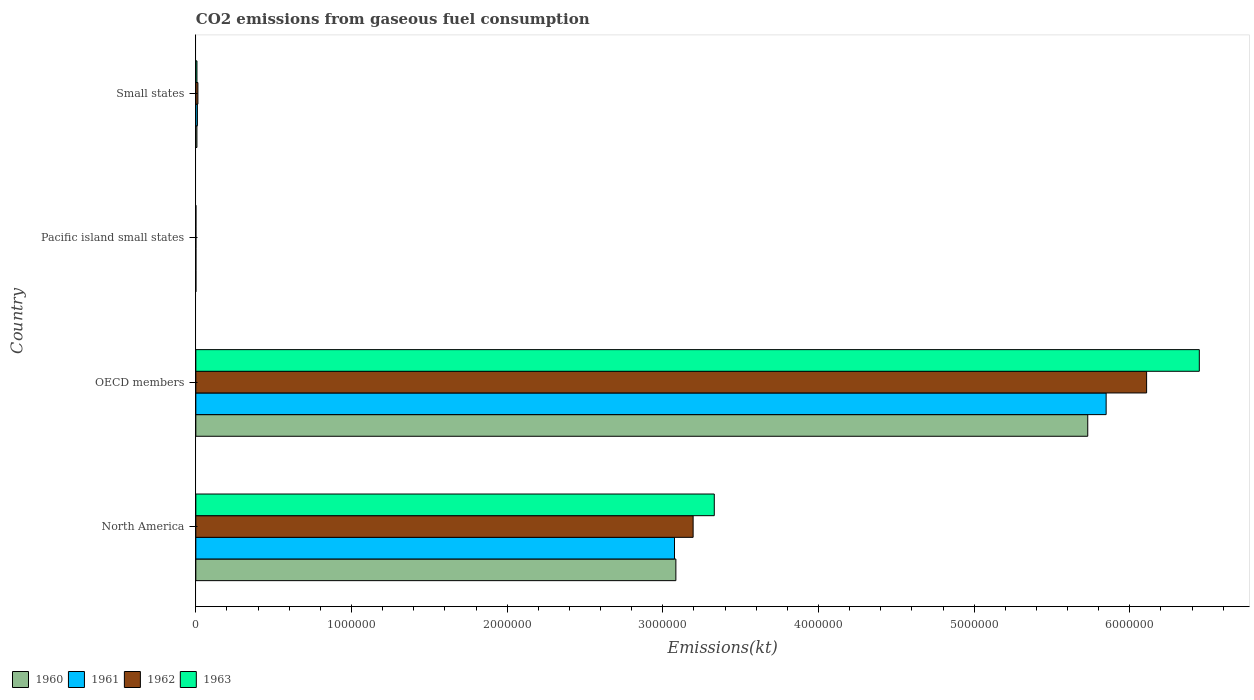Are the number of bars per tick equal to the number of legend labels?
Make the answer very short. Yes. Are the number of bars on each tick of the Y-axis equal?
Your answer should be very brief. Yes. How many bars are there on the 3rd tick from the bottom?
Ensure brevity in your answer.  4. What is the label of the 1st group of bars from the top?
Your answer should be compact. Small states. What is the amount of CO2 emitted in 1961 in North America?
Ensure brevity in your answer.  3.07e+06. Across all countries, what is the maximum amount of CO2 emitted in 1960?
Give a very brief answer. 5.73e+06. Across all countries, what is the minimum amount of CO2 emitted in 1961?
Make the answer very short. 332.61. In which country was the amount of CO2 emitted in 1963 minimum?
Your answer should be very brief. Pacific island small states. What is the total amount of CO2 emitted in 1960 in the graph?
Make the answer very short. 8.82e+06. What is the difference between the amount of CO2 emitted in 1961 in OECD members and that in Pacific island small states?
Offer a very short reply. 5.85e+06. What is the difference between the amount of CO2 emitted in 1962 in OECD members and the amount of CO2 emitted in 1963 in North America?
Make the answer very short. 2.78e+06. What is the average amount of CO2 emitted in 1961 per country?
Your response must be concise. 2.23e+06. What is the difference between the amount of CO2 emitted in 1962 and amount of CO2 emitted in 1960 in Pacific island small states?
Your answer should be very brief. 104. In how many countries, is the amount of CO2 emitted in 1960 greater than 3000000 kt?
Give a very brief answer. 2. What is the ratio of the amount of CO2 emitted in 1960 in North America to that in OECD members?
Offer a very short reply. 0.54. Is the amount of CO2 emitted in 1963 in OECD members less than that in Small states?
Make the answer very short. No. Is the difference between the amount of CO2 emitted in 1962 in Pacific island small states and Small states greater than the difference between the amount of CO2 emitted in 1960 in Pacific island small states and Small states?
Provide a succinct answer. No. What is the difference between the highest and the second highest amount of CO2 emitted in 1963?
Provide a short and direct response. 3.12e+06. What is the difference between the highest and the lowest amount of CO2 emitted in 1963?
Make the answer very short. 6.45e+06. In how many countries, is the amount of CO2 emitted in 1961 greater than the average amount of CO2 emitted in 1961 taken over all countries?
Your response must be concise. 2. Is the sum of the amount of CO2 emitted in 1963 in OECD members and Pacific island small states greater than the maximum amount of CO2 emitted in 1960 across all countries?
Your response must be concise. Yes. What does the 2nd bar from the top in Small states represents?
Your answer should be very brief. 1962. Are all the bars in the graph horizontal?
Offer a very short reply. Yes. Are the values on the major ticks of X-axis written in scientific E-notation?
Your answer should be compact. No. Does the graph contain any zero values?
Provide a succinct answer. No. How many legend labels are there?
Keep it short and to the point. 4. What is the title of the graph?
Provide a short and direct response. CO2 emissions from gaseous fuel consumption. What is the label or title of the X-axis?
Offer a terse response. Emissions(kt). What is the label or title of the Y-axis?
Make the answer very short. Country. What is the Emissions(kt) of 1960 in North America?
Ensure brevity in your answer.  3.08e+06. What is the Emissions(kt) in 1961 in North America?
Keep it short and to the point. 3.07e+06. What is the Emissions(kt) of 1962 in North America?
Your answer should be compact. 3.19e+06. What is the Emissions(kt) of 1963 in North America?
Your answer should be very brief. 3.33e+06. What is the Emissions(kt) in 1960 in OECD members?
Keep it short and to the point. 5.73e+06. What is the Emissions(kt) of 1961 in OECD members?
Keep it short and to the point. 5.85e+06. What is the Emissions(kt) of 1962 in OECD members?
Give a very brief answer. 6.11e+06. What is the Emissions(kt) in 1963 in OECD members?
Your answer should be very brief. 6.45e+06. What is the Emissions(kt) in 1960 in Pacific island small states?
Ensure brevity in your answer.  309.51. What is the Emissions(kt) in 1961 in Pacific island small states?
Ensure brevity in your answer.  332.61. What is the Emissions(kt) of 1962 in Pacific island small states?
Provide a short and direct response. 413.52. What is the Emissions(kt) in 1963 in Pacific island small states?
Give a very brief answer. 433.59. What is the Emissions(kt) of 1960 in Small states?
Your answer should be very brief. 7013.94. What is the Emissions(kt) in 1961 in Small states?
Ensure brevity in your answer.  1.02e+04. What is the Emissions(kt) of 1962 in Small states?
Your answer should be compact. 1.34e+04. What is the Emissions(kt) in 1963 in Small states?
Offer a very short reply. 7256.39. Across all countries, what is the maximum Emissions(kt) of 1960?
Ensure brevity in your answer.  5.73e+06. Across all countries, what is the maximum Emissions(kt) in 1961?
Your answer should be very brief. 5.85e+06. Across all countries, what is the maximum Emissions(kt) in 1962?
Your answer should be very brief. 6.11e+06. Across all countries, what is the maximum Emissions(kt) of 1963?
Your answer should be very brief. 6.45e+06. Across all countries, what is the minimum Emissions(kt) of 1960?
Your answer should be very brief. 309.51. Across all countries, what is the minimum Emissions(kt) of 1961?
Ensure brevity in your answer.  332.61. Across all countries, what is the minimum Emissions(kt) in 1962?
Make the answer very short. 413.52. Across all countries, what is the minimum Emissions(kt) of 1963?
Ensure brevity in your answer.  433.59. What is the total Emissions(kt) in 1960 in the graph?
Keep it short and to the point. 8.82e+06. What is the total Emissions(kt) in 1961 in the graph?
Your response must be concise. 8.93e+06. What is the total Emissions(kt) of 1962 in the graph?
Provide a short and direct response. 9.32e+06. What is the total Emissions(kt) in 1963 in the graph?
Your answer should be very brief. 9.78e+06. What is the difference between the Emissions(kt) of 1960 in North America and that in OECD members?
Offer a terse response. -2.65e+06. What is the difference between the Emissions(kt) in 1961 in North America and that in OECD members?
Provide a succinct answer. -2.77e+06. What is the difference between the Emissions(kt) of 1962 in North America and that in OECD members?
Provide a succinct answer. -2.91e+06. What is the difference between the Emissions(kt) of 1963 in North America and that in OECD members?
Offer a very short reply. -3.12e+06. What is the difference between the Emissions(kt) in 1960 in North America and that in Pacific island small states?
Provide a succinct answer. 3.08e+06. What is the difference between the Emissions(kt) in 1961 in North America and that in Pacific island small states?
Give a very brief answer. 3.07e+06. What is the difference between the Emissions(kt) of 1962 in North America and that in Pacific island small states?
Offer a very short reply. 3.19e+06. What is the difference between the Emissions(kt) of 1963 in North America and that in Pacific island small states?
Ensure brevity in your answer.  3.33e+06. What is the difference between the Emissions(kt) of 1960 in North America and that in Small states?
Your response must be concise. 3.08e+06. What is the difference between the Emissions(kt) in 1961 in North America and that in Small states?
Make the answer very short. 3.06e+06. What is the difference between the Emissions(kt) of 1962 in North America and that in Small states?
Provide a short and direct response. 3.18e+06. What is the difference between the Emissions(kt) of 1963 in North America and that in Small states?
Ensure brevity in your answer.  3.32e+06. What is the difference between the Emissions(kt) in 1960 in OECD members and that in Pacific island small states?
Keep it short and to the point. 5.73e+06. What is the difference between the Emissions(kt) in 1961 in OECD members and that in Pacific island small states?
Your answer should be very brief. 5.85e+06. What is the difference between the Emissions(kt) of 1962 in OECD members and that in Pacific island small states?
Keep it short and to the point. 6.11e+06. What is the difference between the Emissions(kt) of 1963 in OECD members and that in Pacific island small states?
Your answer should be very brief. 6.45e+06. What is the difference between the Emissions(kt) of 1960 in OECD members and that in Small states?
Keep it short and to the point. 5.72e+06. What is the difference between the Emissions(kt) in 1961 in OECD members and that in Small states?
Your answer should be very brief. 5.84e+06. What is the difference between the Emissions(kt) in 1962 in OECD members and that in Small states?
Provide a succinct answer. 6.09e+06. What is the difference between the Emissions(kt) of 1963 in OECD members and that in Small states?
Your answer should be compact. 6.44e+06. What is the difference between the Emissions(kt) in 1960 in Pacific island small states and that in Small states?
Your response must be concise. -6704.42. What is the difference between the Emissions(kt) in 1961 in Pacific island small states and that in Small states?
Offer a very short reply. -9836.23. What is the difference between the Emissions(kt) of 1962 in Pacific island small states and that in Small states?
Provide a succinct answer. -1.30e+04. What is the difference between the Emissions(kt) of 1963 in Pacific island small states and that in Small states?
Keep it short and to the point. -6822.8. What is the difference between the Emissions(kt) in 1960 in North America and the Emissions(kt) in 1961 in OECD members?
Your answer should be compact. -2.76e+06. What is the difference between the Emissions(kt) of 1960 in North America and the Emissions(kt) of 1962 in OECD members?
Your response must be concise. -3.02e+06. What is the difference between the Emissions(kt) of 1960 in North America and the Emissions(kt) of 1963 in OECD members?
Give a very brief answer. -3.36e+06. What is the difference between the Emissions(kt) in 1961 in North America and the Emissions(kt) in 1962 in OECD members?
Provide a succinct answer. -3.03e+06. What is the difference between the Emissions(kt) of 1961 in North America and the Emissions(kt) of 1963 in OECD members?
Keep it short and to the point. -3.37e+06. What is the difference between the Emissions(kt) in 1962 in North America and the Emissions(kt) in 1963 in OECD members?
Provide a succinct answer. -3.25e+06. What is the difference between the Emissions(kt) of 1960 in North America and the Emissions(kt) of 1961 in Pacific island small states?
Provide a short and direct response. 3.08e+06. What is the difference between the Emissions(kt) in 1960 in North America and the Emissions(kt) in 1962 in Pacific island small states?
Give a very brief answer. 3.08e+06. What is the difference between the Emissions(kt) in 1960 in North America and the Emissions(kt) in 1963 in Pacific island small states?
Your answer should be very brief. 3.08e+06. What is the difference between the Emissions(kt) in 1961 in North America and the Emissions(kt) in 1962 in Pacific island small states?
Keep it short and to the point. 3.07e+06. What is the difference between the Emissions(kt) of 1961 in North America and the Emissions(kt) of 1963 in Pacific island small states?
Your response must be concise. 3.07e+06. What is the difference between the Emissions(kt) of 1962 in North America and the Emissions(kt) of 1963 in Pacific island small states?
Keep it short and to the point. 3.19e+06. What is the difference between the Emissions(kt) in 1960 in North America and the Emissions(kt) in 1961 in Small states?
Your response must be concise. 3.07e+06. What is the difference between the Emissions(kt) of 1960 in North America and the Emissions(kt) of 1962 in Small states?
Give a very brief answer. 3.07e+06. What is the difference between the Emissions(kt) in 1960 in North America and the Emissions(kt) in 1963 in Small states?
Make the answer very short. 3.08e+06. What is the difference between the Emissions(kt) in 1961 in North America and the Emissions(kt) in 1962 in Small states?
Provide a short and direct response. 3.06e+06. What is the difference between the Emissions(kt) in 1961 in North America and the Emissions(kt) in 1963 in Small states?
Give a very brief answer. 3.07e+06. What is the difference between the Emissions(kt) in 1962 in North America and the Emissions(kt) in 1963 in Small states?
Your response must be concise. 3.19e+06. What is the difference between the Emissions(kt) in 1960 in OECD members and the Emissions(kt) in 1961 in Pacific island small states?
Give a very brief answer. 5.73e+06. What is the difference between the Emissions(kt) in 1960 in OECD members and the Emissions(kt) in 1962 in Pacific island small states?
Offer a terse response. 5.73e+06. What is the difference between the Emissions(kt) in 1960 in OECD members and the Emissions(kt) in 1963 in Pacific island small states?
Your answer should be compact. 5.73e+06. What is the difference between the Emissions(kt) of 1961 in OECD members and the Emissions(kt) of 1962 in Pacific island small states?
Make the answer very short. 5.85e+06. What is the difference between the Emissions(kt) of 1961 in OECD members and the Emissions(kt) of 1963 in Pacific island small states?
Give a very brief answer. 5.85e+06. What is the difference between the Emissions(kt) in 1962 in OECD members and the Emissions(kt) in 1963 in Pacific island small states?
Give a very brief answer. 6.11e+06. What is the difference between the Emissions(kt) of 1960 in OECD members and the Emissions(kt) of 1961 in Small states?
Provide a succinct answer. 5.72e+06. What is the difference between the Emissions(kt) in 1960 in OECD members and the Emissions(kt) in 1962 in Small states?
Give a very brief answer. 5.72e+06. What is the difference between the Emissions(kt) in 1960 in OECD members and the Emissions(kt) in 1963 in Small states?
Give a very brief answer. 5.72e+06. What is the difference between the Emissions(kt) of 1961 in OECD members and the Emissions(kt) of 1962 in Small states?
Your answer should be very brief. 5.83e+06. What is the difference between the Emissions(kt) in 1961 in OECD members and the Emissions(kt) in 1963 in Small states?
Your answer should be compact. 5.84e+06. What is the difference between the Emissions(kt) in 1962 in OECD members and the Emissions(kt) in 1963 in Small states?
Make the answer very short. 6.10e+06. What is the difference between the Emissions(kt) in 1960 in Pacific island small states and the Emissions(kt) in 1961 in Small states?
Ensure brevity in your answer.  -9859.33. What is the difference between the Emissions(kt) in 1960 in Pacific island small states and the Emissions(kt) in 1962 in Small states?
Keep it short and to the point. -1.31e+04. What is the difference between the Emissions(kt) of 1960 in Pacific island small states and the Emissions(kt) of 1963 in Small states?
Ensure brevity in your answer.  -6946.87. What is the difference between the Emissions(kt) in 1961 in Pacific island small states and the Emissions(kt) in 1962 in Small states?
Offer a very short reply. -1.31e+04. What is the difference between the Emissions(kt) in 1961 in Pacific island small states and the Emissions(kt) in 1963 in Small states?
Your answer should be compact. -6923.78. What is the difference between the Emissions(kt) of 1962 in Pacific island small states and the Emissions(kt) of 1963 in Small states?
Ensure brevity in your answer.  -6842.87. What is the average Emissions(kt) of 1960 per country?
Your answer should be compact. 2.21e+06. What is the average Emissions(kt) of 1961 per country?
Offer a very short reply. 2.23e+06. What is the average Emissions(kt) of 1962 per country?
Provide a short and direct response. 2.33e+06. What is the average Emissions(kt) in 1963 per country?
Your response must be concise. 2.45e+06. What is the difference between the Emissions(kt) of 1960 and Emissions(kt) of 1961 in North America?
Your answer should be compact. 8885.14. What is the difference between the Emissions(kt) in 1960 and Emissions(kt) in 1962 in North America?
Provide a short and direct response. -1.11e+05. What is the difference between the Emissions(kt) in 1960 and Emissions(kt) in 1963 in North America?
Your answer should be very brief. -2.47e+05. What is the difference between the Emissions(kt) of 1961 and Emissions(kt) of 1962 in North America?
Ensure brevity in your answer.  -1.20e+05. What is the difference between the Emissions(kt) of 1961 and Emissions(kt) of 1963 in North America?
Give a very brief answer. -2.56e+05. What is the difference between the Emissions(kt) in 1962 and Emissions(kt) in 1963 in North America?
Provide a short and direct response. -1.36e+05. What is the difference between the Emissions(kt) in 1960 and Emissions(kt) in 1961 in OECD members?
Offer a terse response. -1.18e+05. What is the difference between the Emissions(kt) of 1960 and Emissions(kt) of 1962 in OECD members?
Keep it short and to the point. -3.78e+05. What is the difference between the Emissions(kt) in 1960 and Emissions(kt) in 1963 in OECD members?
Your answer should be compact. -7.17e+05. What is the difference between the Emissions(kt) in 1961 and Emissions(kt) in 1962 in OECD members?
Offer a very short reply. -2.60e+05. What is the difference between the Emissions(kt) of 1961 and Emissions(kt) of 1963 in OECD members?
Keep it short and to the point. -5.99e+05. What is the difference between the Emissions(kt) of 1962 and Emissions(kt) of 1963 in OECD members?
Your answer should be very brief. -3.39e+05. What is the difference between the Emissions(kt) in 1960 and Emissions(kt) in 1961 in Pacific island small states?
Offer a very short reply. -23.1. What is the difference between the Emissions(kt) in 1960 and Emissions(kt) in 1962 in Pacific island small states?
Keep it short and to the point. -104. What is the difference between the Emissions(kt) in 1960 and Emissions(kt) in 1963 in Pacific island small states?
Keep it short and to the point. -124.08. What is the difference between the Emissions(kt) in 1961 and Emissions(kt) in 1962 in Pacific island small states?
Provide a succinct answer. -80.91. What is the difference between the Emissions(kt) of 1961 and Emissions(kt) of 1963 in Pacific island small states?
Your answer should be compact. -100.98. What is the difference between the Emissions(kt) in 1962 and Emissions(kt) in 1963 in Pacific island small states?
Make the answer very short. -20.07. What is the difference between the Emissions(kt) in 1960 and Emissions(kt) in 1961 in Small states?
Provide a short and direct response. -3154.91. What is the difference between the Emissions(kt) in 1960 and Emissions(kt) in 1962 in Small states?
Ensure brevity in your answer.  -6374.72. What is the difference between the Emissions(kt) of 1960 and Emissions(kt) of 1963 in Small states?
Provide a succinct answer. -242.45. What is the difference between the Emissions(kt) in 1961 and Emissions(kt) in 1962 in Small states?
Provide a succinct answer. -3219.81. What is the difference between the Emissions(kt) of 1961 and Emissions(kt) of 1963 in Small states?
Offer a terse response. 2912.46. What is the difference between the Emissions(kt) of 1962 and Emissions(kt) of 1963 in Small states?
Provide a short and direct response. 6132.27. What is the ratio of the Emissions(kt) of 1960 in North America to that in OECD members?
Offer a very short reply. 0.54. What is the ratio of the Emissions(kt) of 1961 in North America to that in OECD members?
Offer a terse response. 0.53. What is the ratio of the Emissions(kt) of 1962 in North America to that in OECD members?
Give a very brief answer. 0.52. What is the ratio of the Emissions(kt) of 1963 in North America to that in OECD members?
Ensure brevity in your answer.  0.52. What is the ratio of the Emissions(kt) in 1960 in North America to that in Pacific island small states?
Offer a terse response. 9963.19. What is the ratio of the Emissions(kt) of 1961 in North America to that in Pacific island small states?
Offer a terse response. 9244.59. What is the ratio of the Emissions(kt) of 1962 in North America to that in Pacific island small states?
Provide a succinct answer. 7725.3. What is the ratio of the Emissions(kt) in 1963 in North America to that in Pacific island small states?
Offer a terse response. 7681.17. What is the ratio of the Emissions(kt) in 1960 in North America to that in Small states?
Your response must be concise. 439.66. What is the ratio of the Emissions(kt) in 1961 in North America to that in Small states?
Your answer should be very brief. 302.38. What is the ratio of the Emissions(kt) of 1962 in North America to that in Small states?
Provide a succinct answer. 238.6. What is the ratio of the Emissions(kt) in 1963 in North America to that in Small states?
Offer a very short reply. 458.97. What is the ratio of the Emissions(kt) in 1960 in OECD members to that in Pacific island small states?
Ensure brevity in your answer.  1.85e+04. What is the ratio of the Emissions(kt) of 1961 in OECD members to that in Pacific island small states?
Your answer should be very brief. 1.76e+04. What is the ratio of the Emissions(kt) in 1962 in OECD members to that in Pacific island small states?
Provide a succinct answer. 1.48e+04. What is the ratio of the Emissions(kt) in 1963 in OECD members to that in Pacific island small states?
Offer a terse response. 1.49e+04. What is the ratio of the Emissions(kt) in 1960 in OECD members to that in Small states?
Give a very brief answer. 816.87. What is the ratio of the Emissions(kt) of 1961 in OECD members to that in Small states?
Your answer should be compact. 575.06. What is the ratio of the Emissions(kt) in 1962 in OECD members to that in Small states?
Offer a very short reply. 456.18. What is the ratio of the Emissions(kt) of 1963 in OECD members to that in Small states?
Provide a short and direct response. 888.35. What is the ratio of the Emissions(kt) in 1960 in Pacific island small states to that in Small states?
Ensure brevity in your answer.  0.04. What is the ratio of the Emissions(kt) of 1961 in Pacific island small states to that in Small states?
Provide a succinct answer. 0.03. What is the ratio of the Emissions(kt) of 1962 in Pacific island small states to that in Small states?
Offer a terse response. 0.03. What is the ratio of the Emissions(kt) in 1963 in Pacific island small states to that in Small states?
Provide a short and direct response. 0.06. What is the difference between the highest and the second highest Emissions(kt) in 1960?
Make the answer very short. 2.65e+06. What is the difference between the highest and the second highest Emissions(kt) of 1961?
Keep it short and to the point. 2.77e+06. What is the difference between the highest and the second highest Emissions(kt) of 1962?
Make the answer very short. 2.91e+06. What is the difference between the highest and the second highest Emissions(kt) of 1963?
Provide a succinct answer. 3.12e+06. What is the difference between the highest and the lowest Emissions(kt) in 1960?
Give a very brief answer. 5.73e+06. What is the difference between the highest and the lowest Emissions(kt) in 1961?
Ensure brevity in your answer.  5.85e+06. What is the difference between the highest and the lowest Emissions(kt) of 1962?
Offer a very short reply. 6.11e+06. What is the difference between the highest and the lowest Emissions(kt) in 1963?
Offer a very short reply. 6.45e+06. 